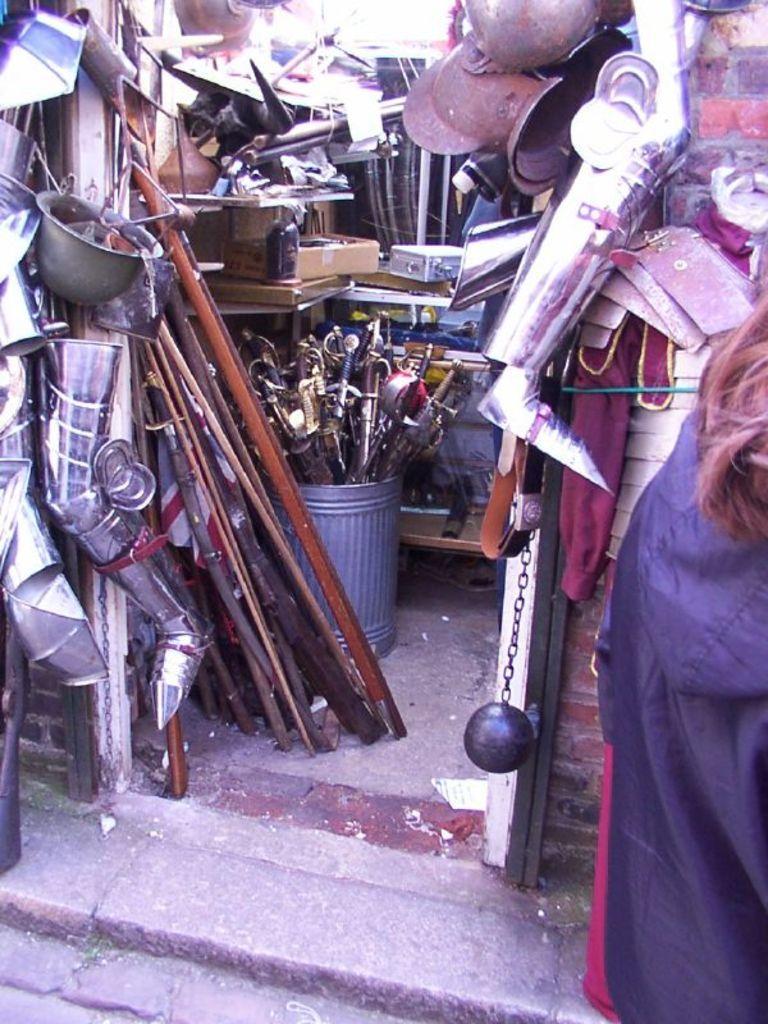Describe this image in one or two sentences. In this image, we can see a person and in the background, there is a wall and we can see some utensils, rods, chains, knives, containers, belts,clothes, a ball and we can see many objects. At the bottom, there is a floor. 